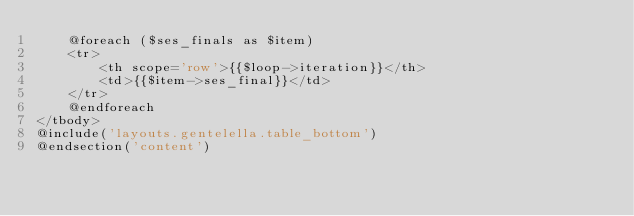Convert code to text. <code><loc_0><loc_0><loc_500><loc_500><_PHP_>    @foreach ($ses_finals as $item)
    <tr>
        <th scope='row'>{{$loop->iteration}}</th>
        <td>{{$item->ses_final}}</td>
    </tr>
    @endforeach
</tbody>
@include('layouts.gentelella.table_bottom')
@endsection('content')
</code> 